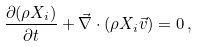<formula> <loc_0><loc_0><loc_500><loc_500>\frac { \partial ( \rho X _ { i } ) } { \partial t } + \vec { \nabla } \cdot ( \rho X _ { i } \vec { v } ) = 0 \, ,</formula> 